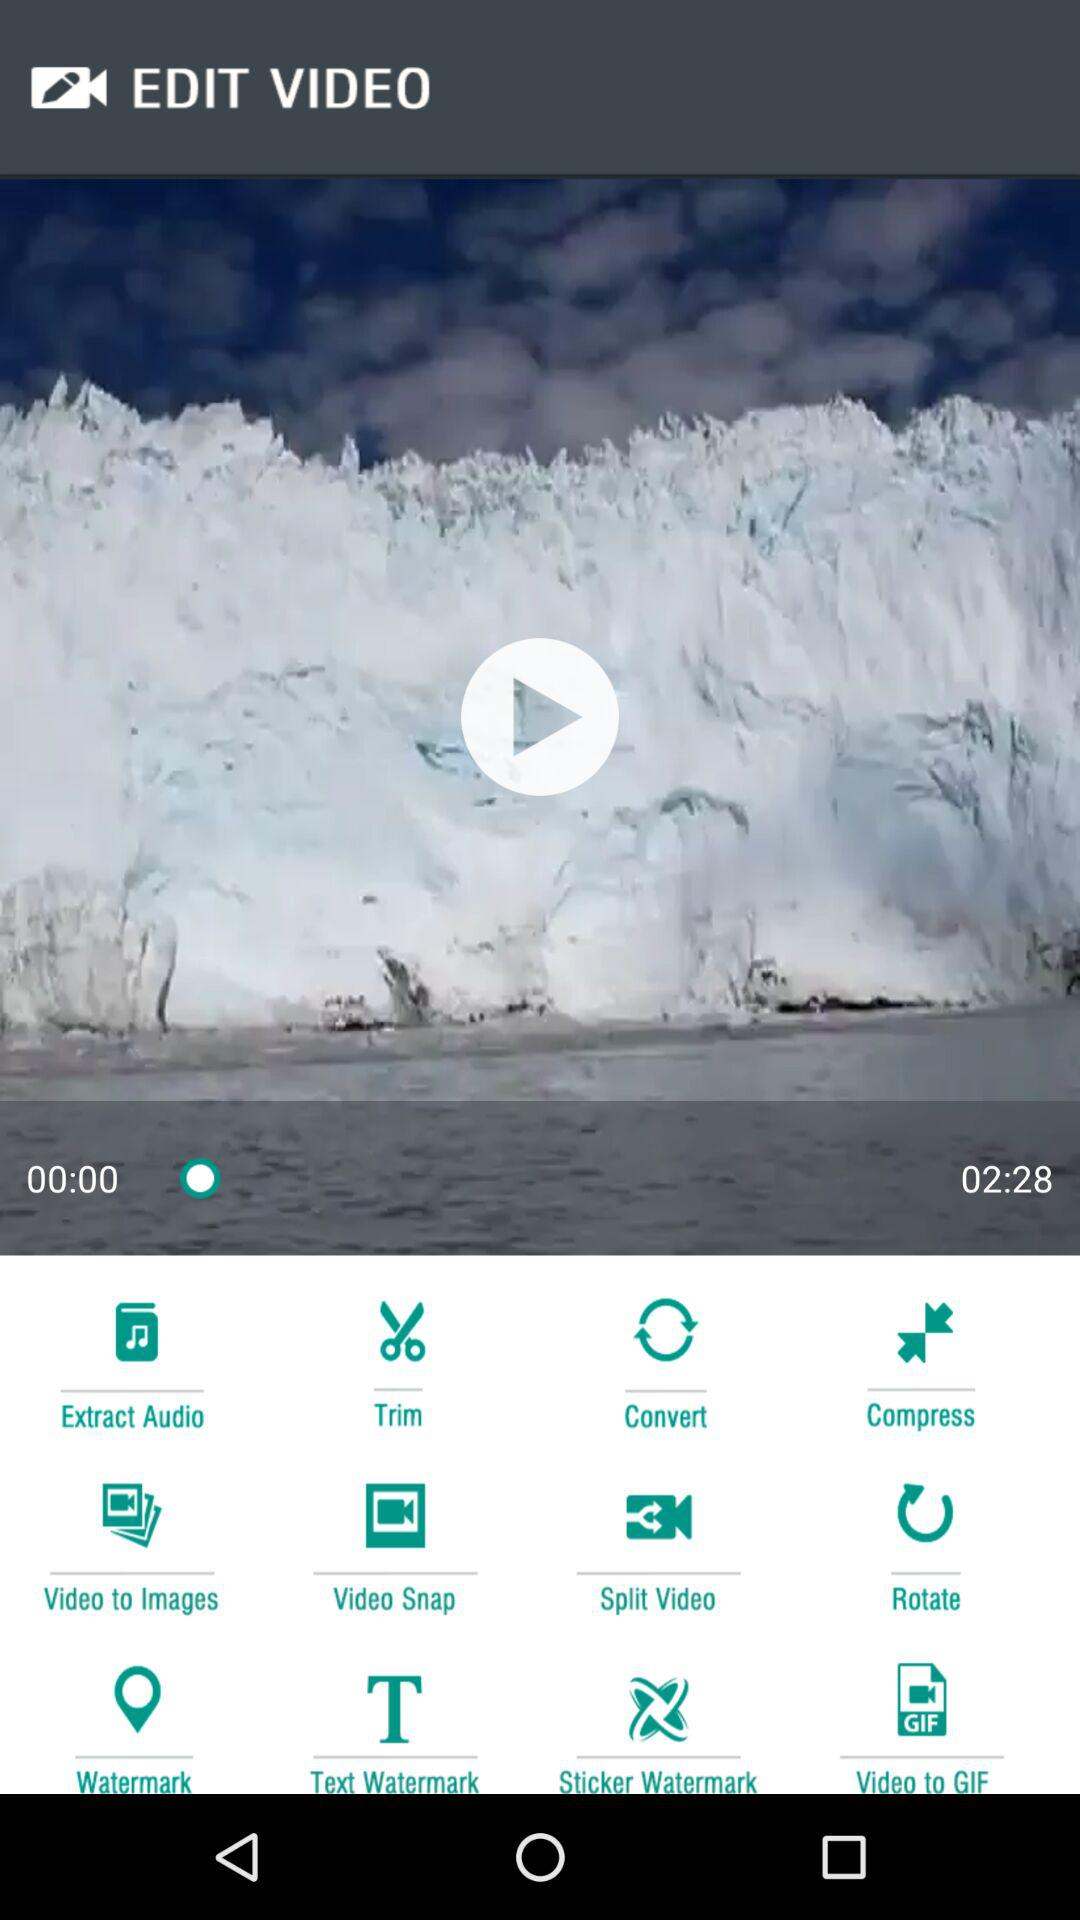What is the duration of the video? The duration of the video is 2 minutes 28 seconds. 